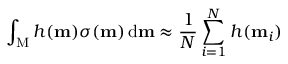<formula> <loc_0><loc_0><loc_500><loc_500>\int _ { M } h ( m ) \sigma ( m ) \, d m \approx \frac { 1 } { N } \sum _ { i = 1 } ^ { N } h ( m _ { i } )</formula> 